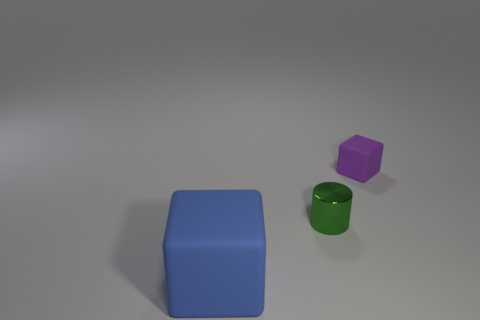Add 1 large red rubber objects. How many objects exist? 4 Subtract all cubes. How many objects are left? 1 Add 3 big things. How many big things exist? 4 Subtract 0 gray spheres. How many objects are left? 3 Subtract all blue things. Subtract all tiny purple rubber objects. How many objects are left? 1 Add 1 small purple things. How many small purple things are left? 2 